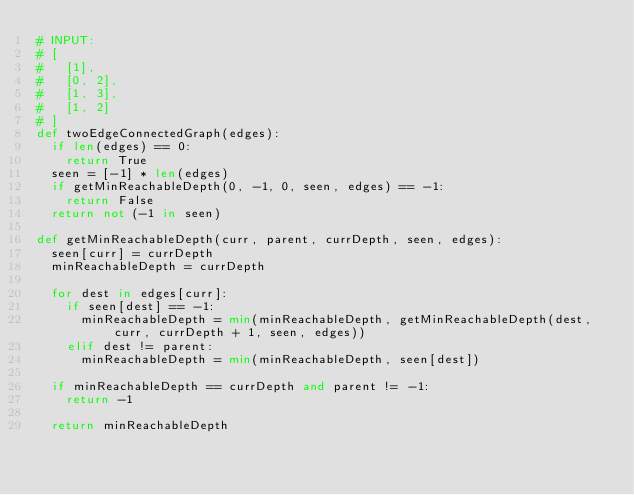Convert code to text. <code><loc_0><loc_0><loc_500><loc_500><_Python_># INPUT: 
# [
#   [1],
#   [0, 2],
#   [1, 3],
#   [1, 2]
# ]
def twoEdgeConnectedGraph(edges):
	if len(edges) == 0:
		return True
	seen = [-1] * len(edges)
	if getMinReachableDepth(0, -1, 0, seen, edges) == -1:
		return False
	return not (-1 in seen)

def getMinReachableDepth(curr, parent, currDepth, seen, edges):
	seen[curr] = currDepth
	minReachableDepth = currDepth
	
	for dest in edges[curr]:
		if seen[dest] == -1:
			minReachableDepth = min(minReachableDepth, getMinReachableDepth(dest, curr, currDepth + 1, seen, edges))
		elif dest != parent:
			minReachableDepth = min(minReachableDepth, seen[dest])
	
	if minReachableDepth == currDepth and parent != -1:
		return -1
	
	return minReachableDepth</code> 